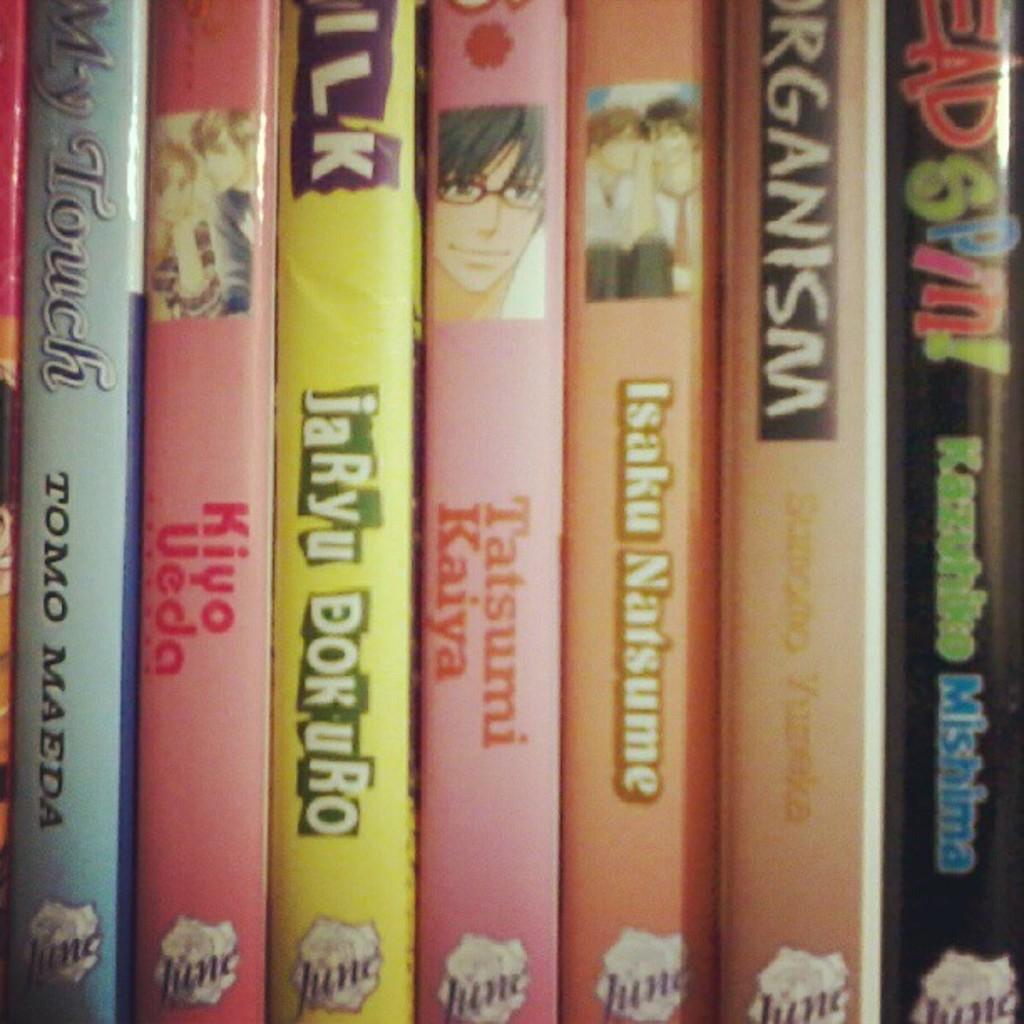What is the name of the blue book?
Make the answer very short. My touch. 